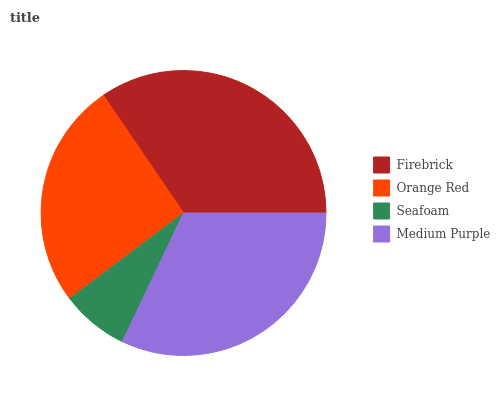Is Seafoam the minimum?
Answer yes or no. Yes. Is Firebrick the maximum?
Answer yes or no. Yes. Is Orange Red the minimum?
Answer yes or no. No. Is Orange Red the maximum?
Answer yes or no. No. Is Firebrick greater than Orange Red?
Answer yes or no. Yes. Is Orange Red less than Firebrick?
Answer yes or no. Yes. Is Orange Red greater than Firebrick?
Answer yes or no. No. Is Firebrick less than Orange Red?
Answer yes or no. No. Is Medium Purple the high median?
Answer yes or no. Yes. Is Orange Red the low median?
Answer yes or no. Yes. Is Seafoam the high median?
Answer yes or no. No. Is Seafoam the low median?
Answer yes or no. No. 